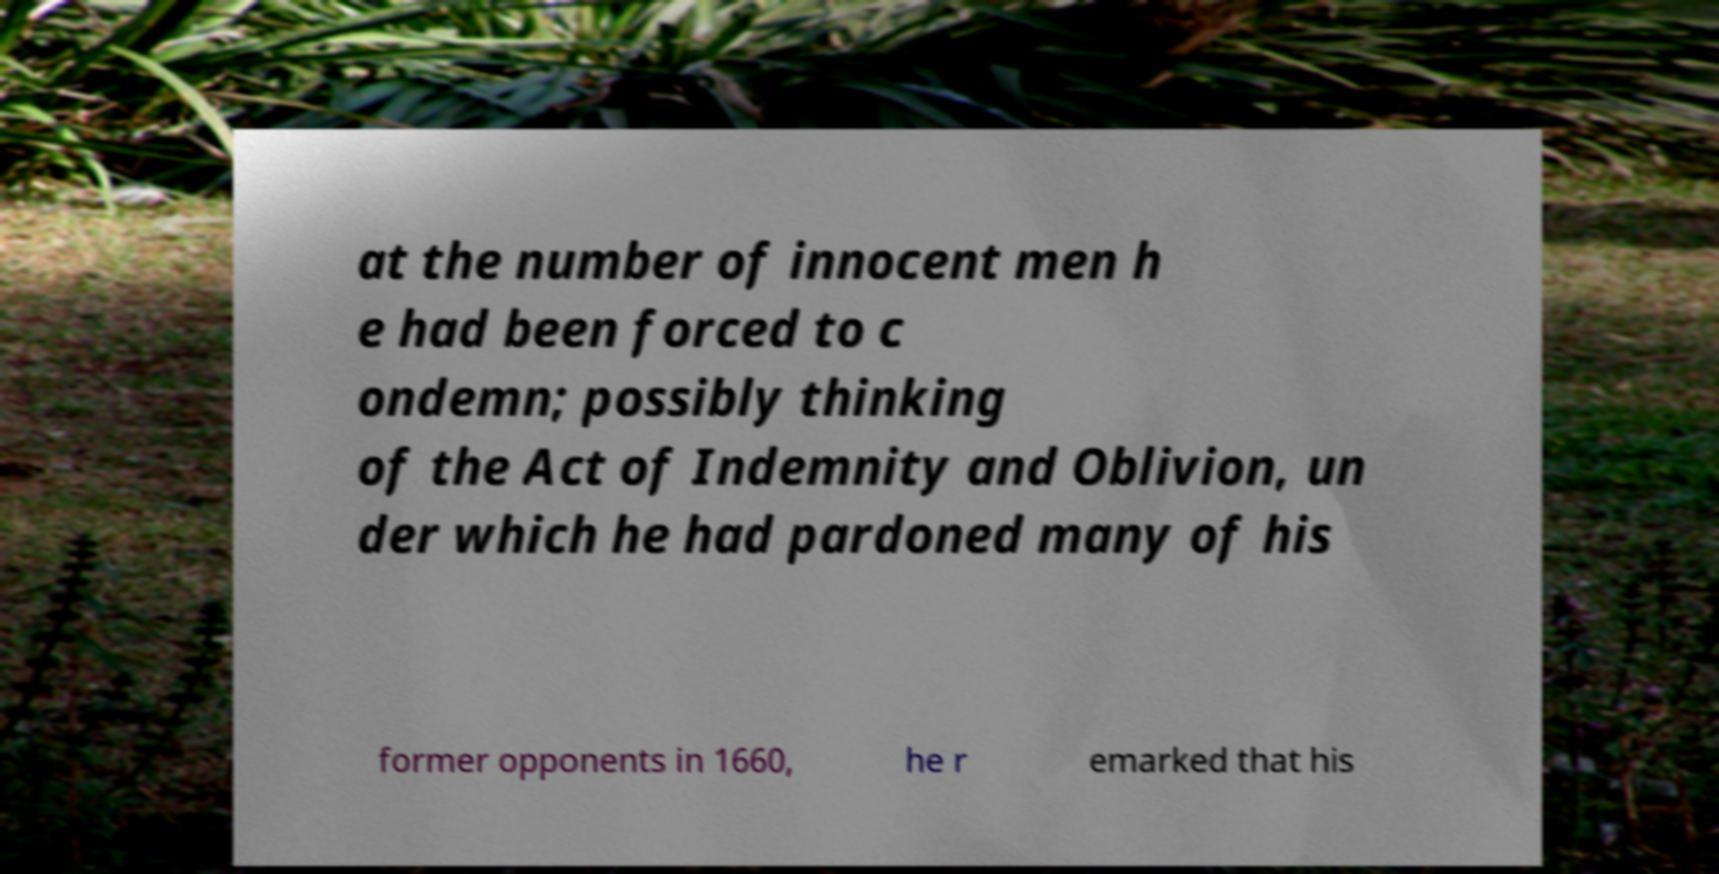There's text embedded in this image that I need extracted. Can you transcribe it verbatim? at the number of innocent men h e had been forced to c ondemn; possibly thinking of the Act of Indemnity and Oblivion, un der which he had pardoned many of his former opponents in 1660, he r emarked that his 